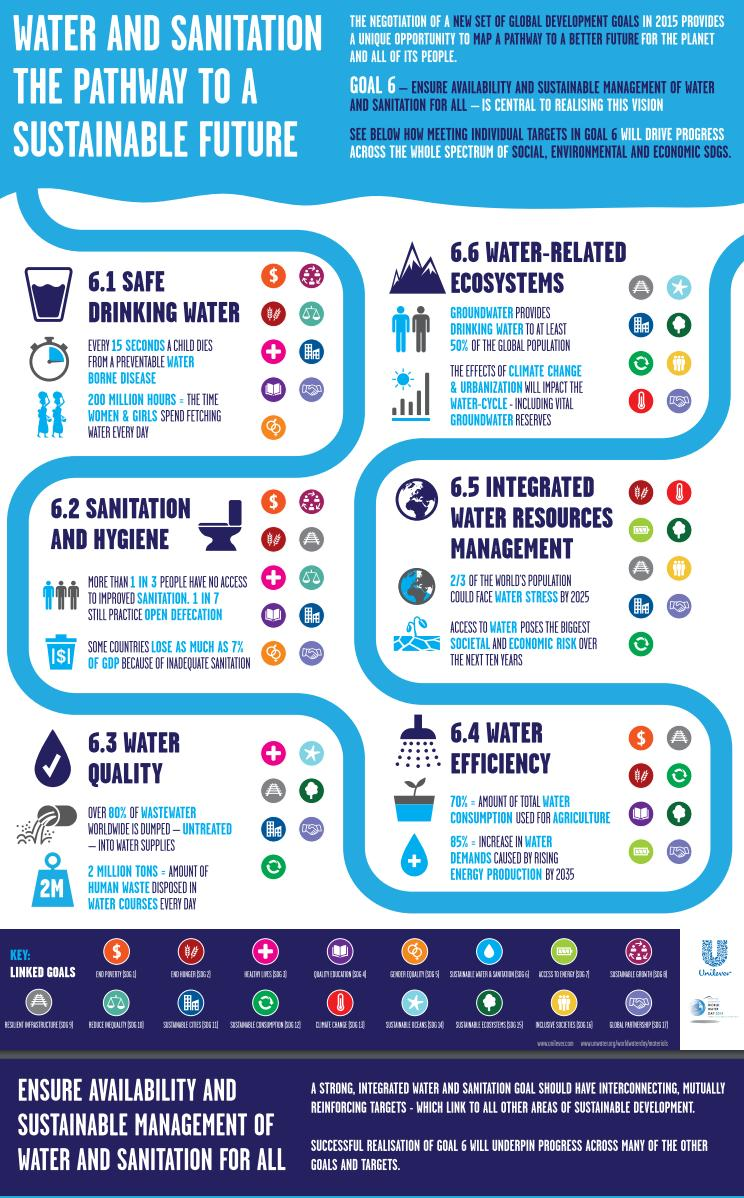Mention a couple of crucial points in this snapshot. Approximately 70% of the total water consumed globally is used for agriculture purposes, By 2025, it is projected that over two-thirds of the world's population will face water stress, meaning that they will not have access to safe and clean water. Approximately 2 million tons of human waste are disposed into water courses every day. It is estimated that at least 50% of the global population relies on ground water as their primary source of drinking water. Every day, over 200 million women and girls around the world spend a significant amount of time fetching water, resulting in a total of 200 million hours of time lost. 